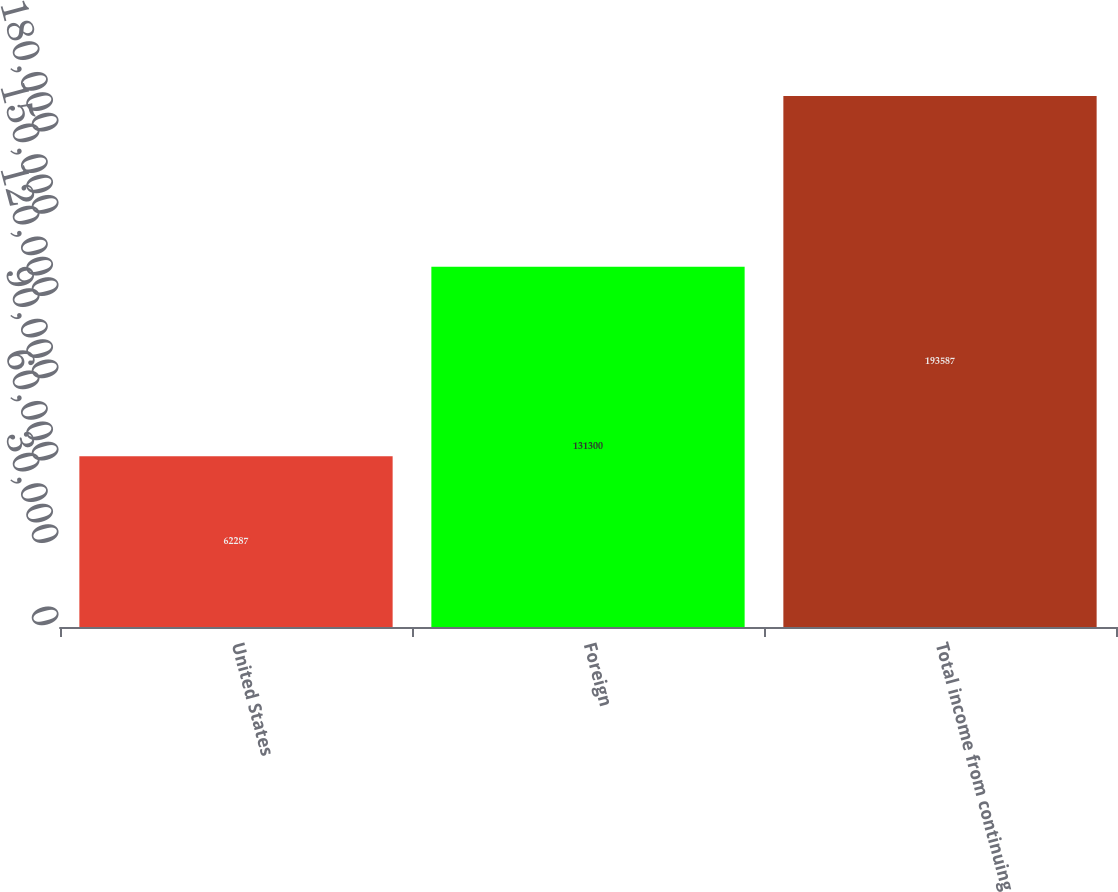Convert chart to OTSL. <chart><loc_0><loc_0><loc_500><loc_500><bar_chart><fcel>United States<fcel>Foreign<fcel>Total income from continuing<nl><fcel>62287<fcel>131300<fcel>193587<nl></chart> 